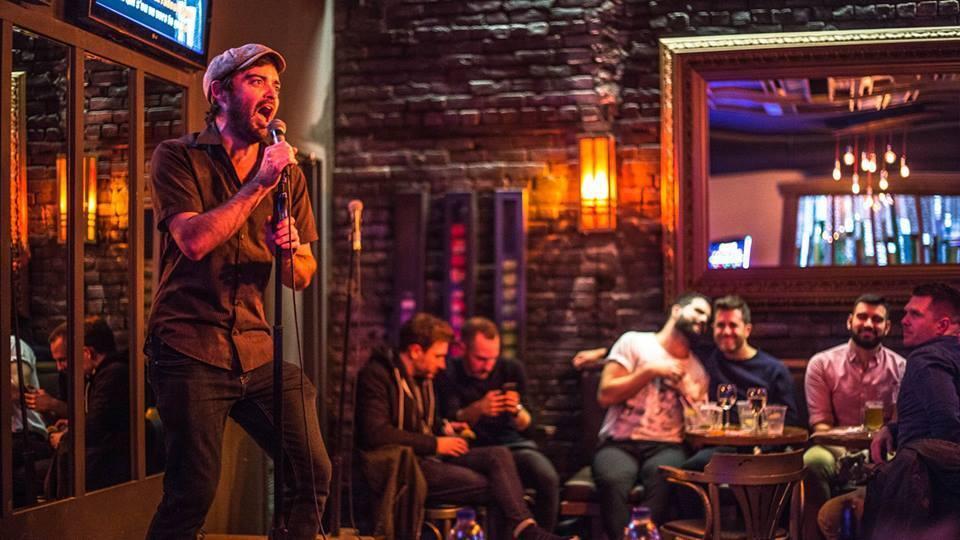What kind of event does the setting imply, and how does it influence the interaction of the people? The setting, with its ambient lighting, a singer performing, and a bar environment, suggests that this is a casual entertainment venue, likely a comedy or live music night. This ambiance encourages a laid-back, interactive atmosphere among attendees where laughter and conversation flow freely. The event directs the group's attention at times towards the performer, adding a communal feel to their interactions. 